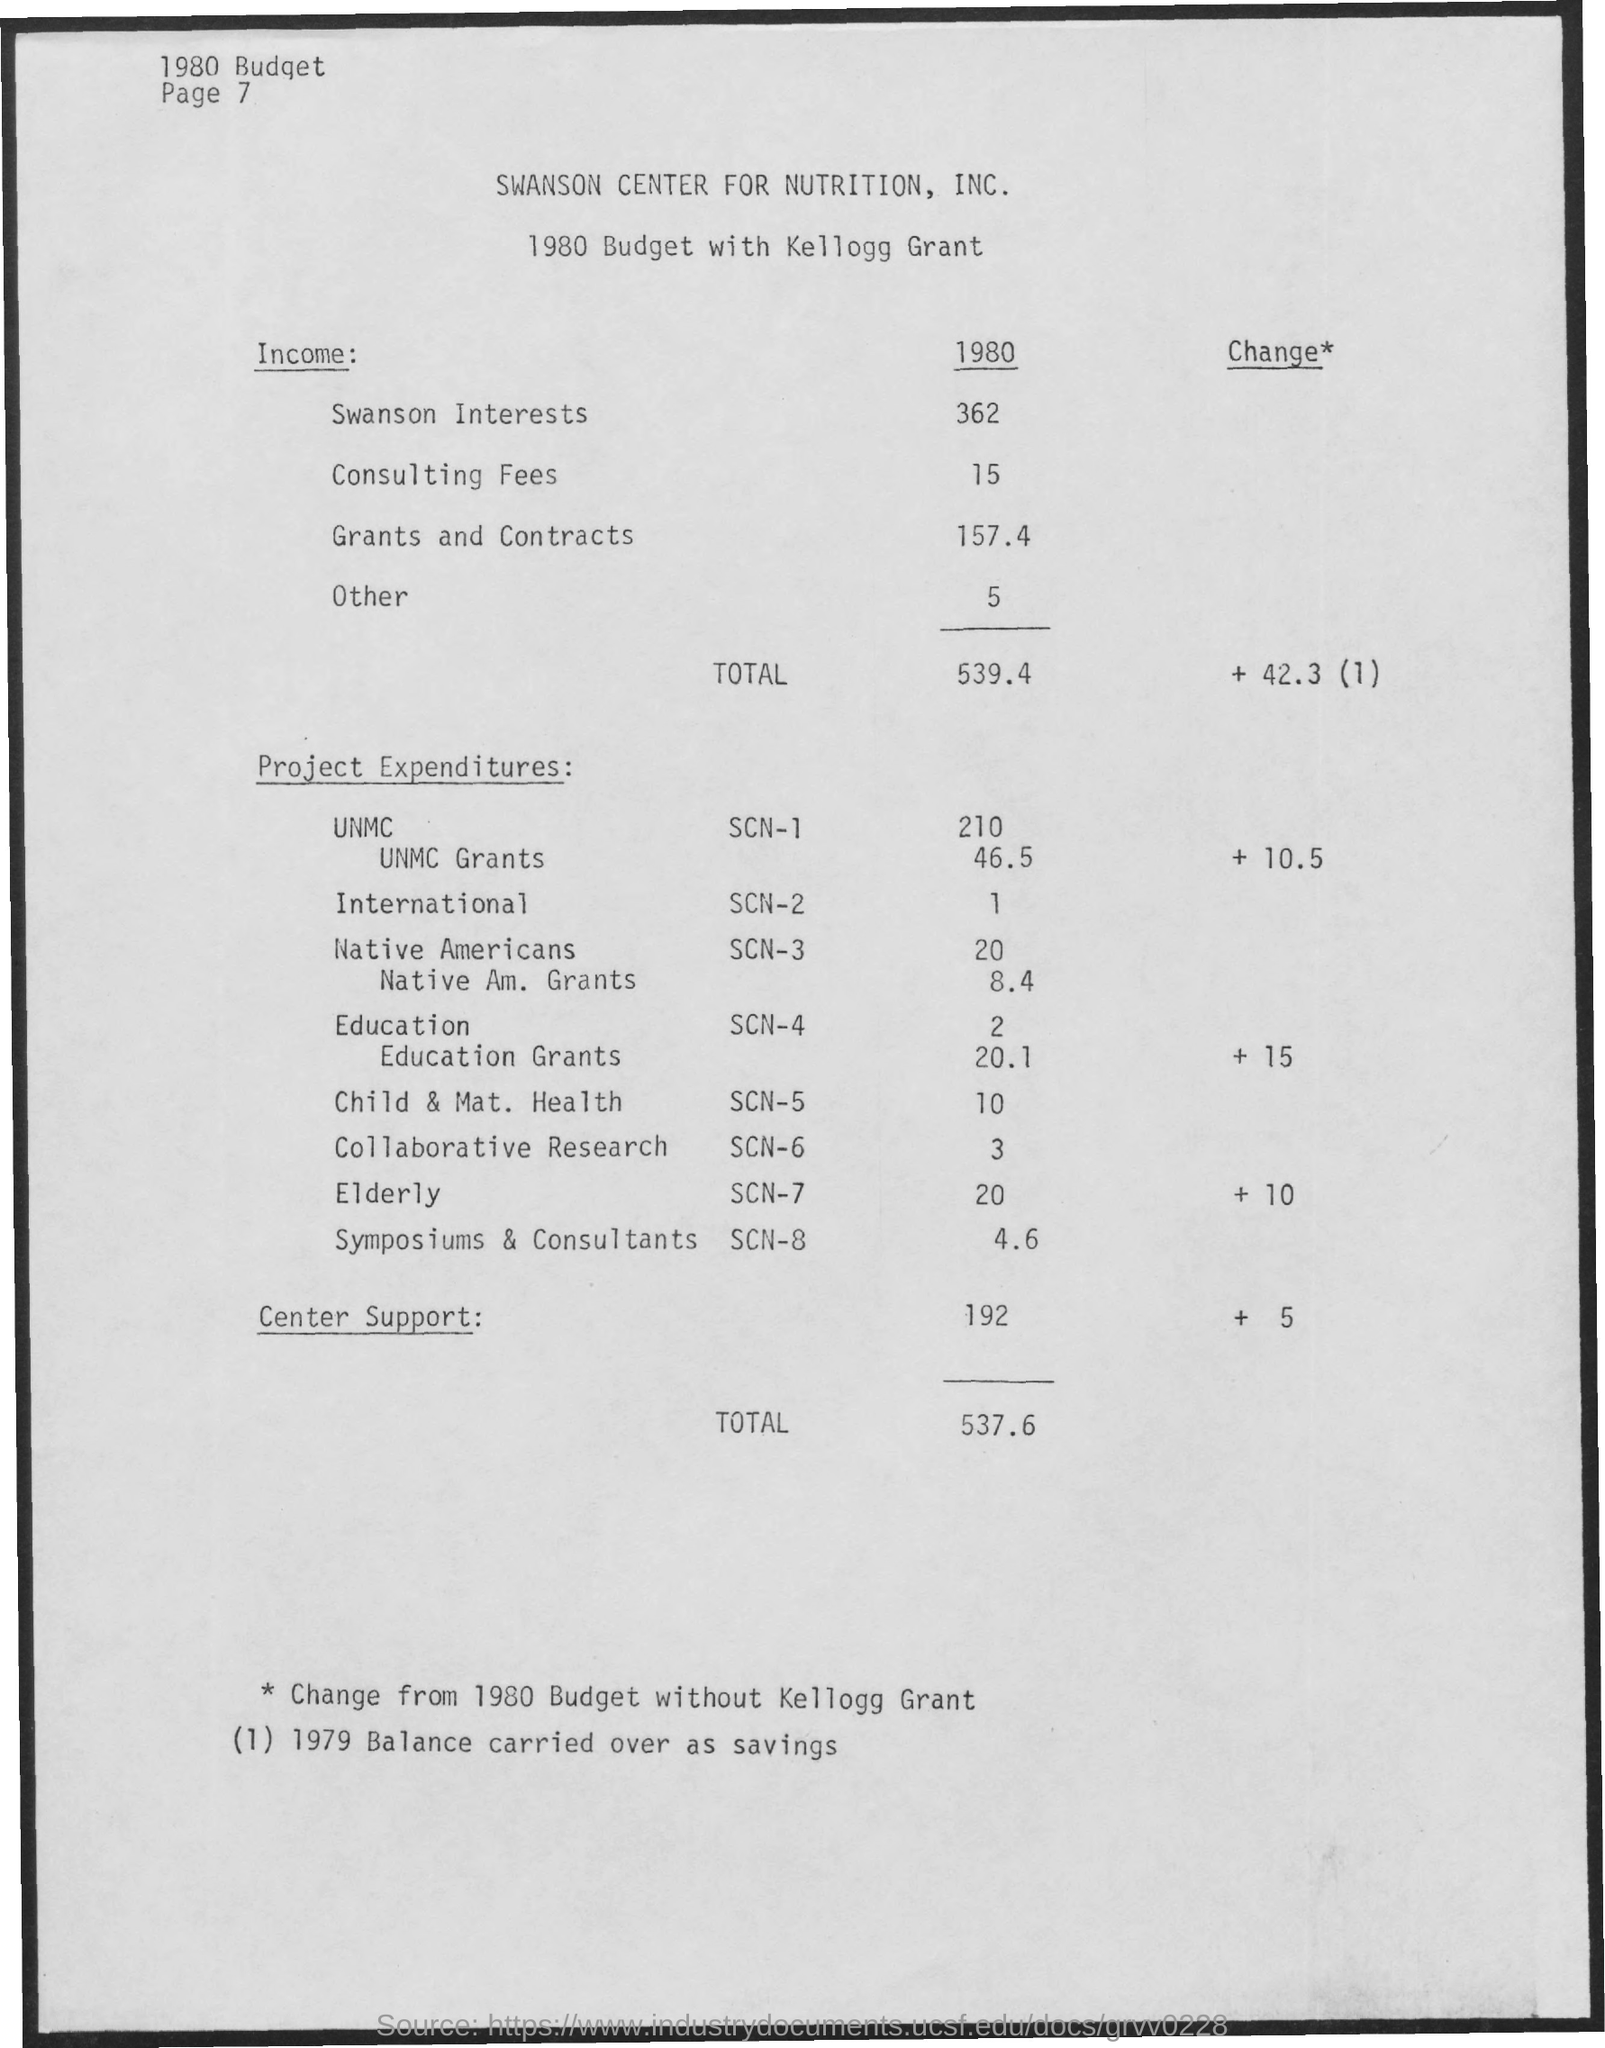What is the income from Swanson Interests in 1980?
Your answer should be compact. 362. What is the income from Consulting fees in 1980?
Your answer should be compact. 15. What is the income from Grants and contracts in 1980?
Your response must be concise. 157.4. What is the total income?
Make the answer very short. 539.4. What is the Project expenditure for UNMC SCN-1?
Provide a short and direct response. 210. What is the Project expenditure for International SCN-2?
Ensure brevity in your answer.  1. What is the Project expenditure for Native Americans SCN-3?
Your response must be concise. 20. What is the Project expenditure for Education SCN-4?
Keep it short and to the point. 2. What is the Project expenditure for Elderly SCN-7?
Your answer should be compact. 20. 